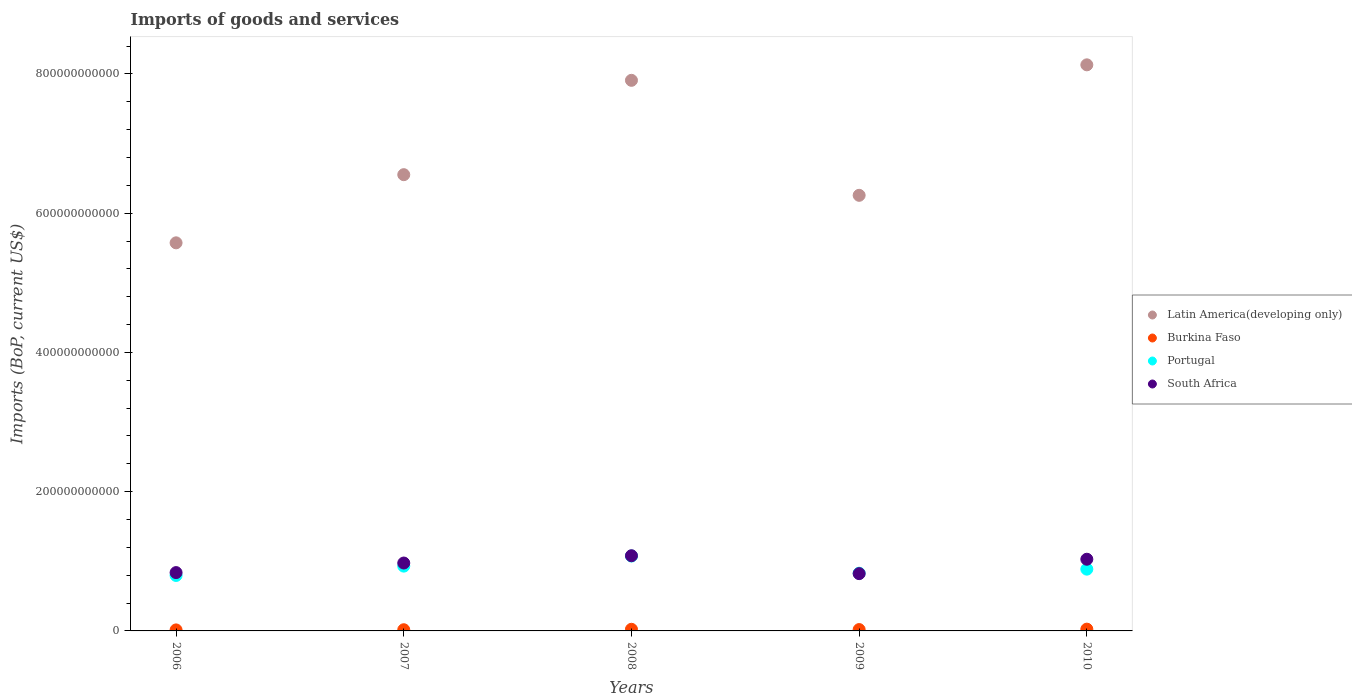What is the amount spent on imports in Latin America(developing only) in 2008?
Make the answer very short. 7.91e+11. Across all years, what is the maximum amount spent on imports in Latin America(developing only)?
Give a very brief answer. 8.13e+11. Across all years, what is the minimum amount spent on imports in Latin America(developing only)?
Your response must be concise. 5.57e+11. In which year was the amount spent on imports in South Africa maximum?
Provide a succinct answer. 2008. In which year was the amount spent on imports in Latin America(developing only) minimum?
Your answer should be compact. 2006. What is the total amount spent on imports in Portugal in the graph?
Give a very brief answer. 4.52e+11. What is the difference between the amount spent on imports in Burkina Faso in 2008 and that in 2009?
Offer a very short reply. 4.11e+08. What is the difference between the amount spent on imports in Latin America(developing only) in 2009 and the amount spent on imports in Burkina Faso in 2007?
Your response must be concise. 6.24e+11. What is the average amount spent on imports in Burkina Faso per year?
Your answer should be very brief. 2.00e+09. In the year 2010, what is the difference between the amount spent on imports in South Africa and amount spent on imports in Portugal?
Offer a very short reply. 1.42e+1. What is the ratio of the amount spent on imports in Burkina Faso in 2008 to that in 2009?
Your answer should be compact. 1.21. Is the amount spent on imports in Burkina Faso in 2009 less than that in 2010?
Give a very brief answer. Yes. What is the difference between the highest and the second highest amount spent on imports in Latin America(developing only)?
Your answer should be very brief. 2.23e+1. What is the difference between the highest and the lowest amount spent on imports in Portugal?
Your answer should be compact. 2.79e+1. Is the sum of the amount spent on imports in Burkina Faso in 2006 and 2009 greater than the maximum amount spent on imports in Latin America(developing only) across all years?
Give a very brief answer. No. Is it the case that in every year, the sum of the amount spent on imports in South Africa and amount spent on imports in Latin America(developing only)  is greater than the amount spent on imports in Burkina Faso?
Keep it short and to the point. Yes. How many dotlines are there?
Keep it short and to the point. 4. What is the difference between two consecutive major ticks on the Y-axis?
Provide a succinct answer. 2.00e+11. Are the values on the major ticks of Y-axis written in scientific E-notation?
Keep it short and to the point. No. Does the graph contain grids?
Your answer should be compact. No. How many legend labels are there?
Provide a short and direct response. 4. What is the title of the graph?
Keep it short and to the point. Imports of goods and services. Does "Congo (Democratic)" appear as one of the legend labels in the graph?
Provide a short and direct response. No. What is the label or title of the X-axis?
Your answer should be very brief. Years. What is the label or title of the Y-axis?
Provide a short and direct response. Imports (BoP, current US$). What is the Imports (BoP, current US$) of Latin America(developing only) in 2006?
Your answer should be very brief. 5.57e+11. What is the Imports (BoP, current US$) in Burkina Faso in 2006?
Offer a very short reply. 1.45e+09. What is the Imports (BoP, current US$) in Portugal in 2006?
Your answer should be very brief. 7.96e+1. What is the Imports (BoP, current US$) in South Africa in 2006?
Provide a short and direct response. 8.38e+1. What is the Imports (BoP, current US$) in Latin America(developing only) in 2007?
Your answer should be very brief. 6.55e+11. What is the Imports (BoP, current US$) of Burkina Faso in 2007?
Keep it short and to the point. 1.70e+09. What is the Imports (BoP, current US$) of Portugal in 2007?
Give a very brief answer. 9.31e+1. What is the Imports (BoP, current US$) of South Africa in 2007?
Provide a succinct answer. 9.75e+1. What is the Imports (BoP, current US$) in Latin America(developing only) in 2008?
Provide a short and direct response. 7.91e+11. What is the Imports (BoP, current US$) in Burkina Faso in 2008?
Give a very brief answer. 2.35e+09. What is the Imports (BoP, current US$) in Portugal in 2008?
Give a very brief answer. 1.08e+11. What is the Imports (BoP, current US$) in South Africa in 2008?
Give a very brief answer. 1.08e+11. What is the Imports (BoP, current US$) in Latin America(developing only) in 2009?
Provide a short and direct response. 6.26e+11. What is the Imports (BoP, current US$) in Burkina Faso in 2009?
Keep it short and to the point. 1.94e+09. What is the Imports (BoP, current US$) in Portugal in 2009?
Ensure brevity in your answer.  8.29e+1. What is the Imports (BoP, current US$) in South Africa in 2009?
Your answer should be compact. 8.23e+1. What is the Imports (BoP, current US$) of Latin America(developing only) in 2010?
Your response must be concise. 8.13e+11. What is the Imports (BoP, current US$) of Burkina Faso in 2010?
Offer a very short reply. 2.56e+09. What is the Imports (BoP, current US$) in Portugal in 2010?
Make the answer very short. 8.87e+1. What is the Imports (BoP, current US$) in South Africa in 2010?
Provide a succinct answer. 1.03e+11. Across all years, what is the maximum Imports (BoP, current US$) of Latin America(developing only)?
Offer a terse response. 8.13e+11. Across all years, what is the maximum Imports (BoP, current US$) of Burkina Faso?
Give a very brief answer. 2.56e+09. Across all years, what is the maximum Imports (BoP, current US$) of Portugal?
Your answer should be very brief. 1.08e+11. Across all years, what is the maximum Imports (BoP, current US$) of South Africa?
Offer a very short reply. 1.08e+11. Across all years, what is the minimum Imports (BoP, current US$) in Latin America(developing only)?
Keep it short and to the point. 5.57e+11. Across all years, what is the minimum Imports (BoP, current US$) of Burkina Faso?
Make the answer very short. 1.45e+09. Across all years, what is the minimum Imports (BoP, current US$) of Portugal?
Your answer should be compact. 7.96e+1. Across all years, what is the minimum Imports (BoP, current US$) in South Africa?
Your response must be concise. 8.23e+1. What is the total Imports (BoP, current US$) of Latin America(developing only) in the graph?
Ensure brevity in your answer.  3.44e+12. What is the total Imports (BoP, current US$) of Burkina Faso in the graph?
Offer a terse response. 1.00e+1. What is the total Imports (BoP, current US$) in Portugal in the graph?
Your answer should be compact. 4.52e+11. What is the total Imports (BoP, current US$) in South Africa in the graph?
Provide a succinct answer. 4.74e+11. What is the difference between the Imports (BoP, current US$) in Latin America(developing only) in 2006 and that in 2007?
Keep it short and to the point. -9.79e+1. What is the difference between the Imports (BoP, current US$) of Burkina Faso in 2006 and that in 2007?
Provide a short and direct response. -2.51e+08. What is the difference between the Imports (BoP, current US$) in Portugal in 2006 and that in 2007?
Your answer should be very brief. -1.34e+1. What is the difference between the Imports (BoP, current US$) in South Africa in 2006 and that in 2007?
Provide a short and direct response. -1.37e+1. What is the difference between the Imports (BoP, current US$) in Latin America(developing only) in 2006 and that in 2008?
Keep it short and to the point. -2.33e+11. What is the difference between the Imports (BoP, current US$) of Burkina Faso in 2006 and that in 2008?
Your answer should be very brief. -9.02e+08. What is the difference between the Imports (BoP, current US$) in Portugal in 2006 and that in 2008?
Keep it short and to the point. -2.79e+1. What is the difference between the Imports (BoP, current US$) of South Africa in 2006 and that in 2008?
Make the answer very short. -2.42e+1. What is the difference between the Imports (BoP, current US$) of Latin America(developing only) in 2006 and that in 2009?
Keep it short and to the point. -6.82e+1. What is the difference between the Imports (BoP, current US$) in Burkina Faso in 2006 and that in 2009?
Keep it short and to the point. -4.91e+08. What is the difference between the Imports (BoP, current US$) of Portugal in 2006 and that in 2009?
Provide a short and direct response. -3.25e+09. What is the difference between the Imports (BoP, current US$) in South Africa in 2006 and that in 2009?
Your answer should be very brief. 1.49e+09. What is the difference between the Imports (BoP, current US$) of Latin America(developing only) in 2006 and that in 2010?
Offer a very short reply. -2.56e+11. What is the difference between the Imports (BoP, current US$) of Burkina Faso in 2006 and that in 2010?
Provide a succinct answer. -1.11e+09. What is the difference between the Imports (BoP, current US$) in Portugal in 2006 and that in 2010?
Ensure brevity in your answer.  -9.06e+09. What is the difference between the Imports (BoP, current US$) of South Africa in 2006 and that in 2010?
Offer a very short reply. -1.92e+1. What is the difference between the Imports (BoP, current US$) of Latin America(developing only) in 2007 and that in 2008?
Give a very brief answer. -1.36e+11. What is the difference between the Imports (BoP, current US$) in Burkina Faso in 2007 and that in 2008?
Keep it short and to the point. -6.51e+08. What is the difference between the Imports (BoP, current US$) in Portugal in 2007 and that in 2008?
Your response must be concise. -1.45e+1. What is the difference between the Imports (BoP, current US$) in South Africa in 2007 and that in 2008?
Give a very brief answer. -1.05e+1. What is the difference between the Imports (BoP, current US$) in Latin America(developing only) in 2007 and that in 2009?
Offer a terse response. 2.96e+1. What is the difference between the Imports (BoP, current US$) of Burkina Faso in 2007 and that in 2009?
Provide a short and direct response. -2.40e+08. What is the difference between the Imports (BoP, current US$) of Portugal in 2007 and that in 2009?
Keep it short and to the point. 1.02e+1. What is the difference between the Imports (BoP, current US$) of South Africa in 2007 and that in 2009?
Make the answer very short. 1.52e+1. What is the difference between the Imports (BoP, current US$) of Latin America(developing only) in 2007 and that in 2010?
Offer a very short reply. -1.58e+11. What is the difference between the Imports (BoP, current US$) of Burkina Faso in 2007 and that in 2010?
Provide a short and direct response. -8.55e+08. What is the difference between the Imports (BoP, current US$) in Portugal in 2007 and that in 2010?
Ensure brevity in your answer.  4.36e+09. What is the difference between the Imports (BoP, current US$) in South Africa in 2007 and that in 2010?
Your answer should be compact. -5.45e+09. What is the difference between the Imports (BoP, current US$) of Latin America(developing only) in 2008 and that in 2009?
Offer a very short reply. 1.65e+11. What is the difference between the Imports (BoP, current US$) of Burkina Faso in 2008 and that in 2009?
Ensure brevity in your answer.  4.11e+08. What is the difference between the Imports (BoP, current US$) of Portugal in 2008 and that in 2009?
Your answer should be very brief. 2.47e+1. What is the difference between the Imports (BoP, current US$) in South Africa in 2008 and that in 2009?
Provide a succinct answer. 2.57e+1. What is the difference between the Imports (BoP, current US$) of Latin America(developing only) in 2008 and that in 2010?
Provide a succinct answer. -2.23e+1. What is the difference between the Imports (BoP, current US$) in Burkina Faso in 2008 and that in 2010?
Your answer should be compact. -2.04e+08. What is the difference between the Imports (BoP, current US$) of Portugal in 2008 and that in 2010?
Make the answer very short. 1.89e+1. What is the difference between the Imports (BoP, current US$) in South Africa in 2008 and that in 2010?
Give a very brief answer. 5.02e+09. What is the difference between the Imports (BoP, current US$) in Latin America(developing only) in 2009 and that in 2010?
Provide a short and direct response. -1.87e+11. What is the difference between the Imports (BoP, current US$) in Burkina Faso in 2009 and that in 2010?
Ensure brevity in your answer.  -6.15e+08. What is the difference between the Imports (BoP, current US$) in Portugal in 2009 and that in 2010?
Offer a terse response. -5.81e+09. What is the difference between the Imports (BoP, current US$) of South Africa in 2009 and that in 2010?
Offer a very short reply. -2.07e+1. What is the difference between the Imports (BoP, current US$) in Latin America(developing only) in 2006 and the Imports (BoP, current US$) in Burkina Faso in 2007?
Your answer should be very brief. 5.56e+11. What is the difference between the Imports (BoP, current US$) in Latin America(developing only) in 2006 and the Imports (BoP, current US$) in Portugal in 2007?
Your response must be concise. 4.64e+11. What is the difference between the Imports (BoP, current US$) in Latin America(developing only) in 2006 and the Imports (BoP, current US$) in South Africa in 2007?
Provide a succinct answer. 4.60e+11. What is the difference between the Imports (BoP, current US$) in Burkina Faso in 2006 and the Imports (BoP, current US$) in Portugal in 2007?
Offer a terse response. -9.16e+1. What is the difference between the Imports (BoP, current US$) of Burkina Faso in 2006 and the Imports (BoP, current US$) of South Africa in 2007?
Your answer should be compact. -9.61e+1. What is the difference between the Imports (BoP, current US$) in Portugal in 2006 and the Imports (BoP, current US$) in South Africa in 2007?
Offer a terse response. -1.79e+1. What is the difference between the Imports (BoP, current US$) of Latin America(developing only) in 2006 and the Imports (BoP, current US$) of Burkina Faso in 2008?
Keep it short and to the point. 5.55e+11. What is the difference between the Imports (BoP, current US$) in Latin America(developing only) in 2006 and the Imports (BoP, current US$) in Portugal in 2008?
Give a very brief answer. 4.50e+11. What is the difference between the Imports (BoP, current US$) of Latin America(developing only) in 2006 and the Imports (BoP, current US$) of South Africa in 2008?
Give a very brief answer. 4.49e+11. What is the difference between the Imports (BoP, current US$) in Burkina Faso in 2006 and the Imports (BoP, current US$) in Portugal in 2008?
Make the answer very short. -1.06e+11. What is the difference between the Imports (BoP, current US$) of Burkina Faso in 2006 and the Imports (BoP, current US$) of South Africa in 2008?
Provide a succinct answer. -1.07e+11. What is the difference between the Imports (BoP, current US$) in Portugal in 2006 and the Imports (BoP, current US$) in South Africa in 2008?
Provide a short and direct response. -2.83e+1. What is the difference between the Imports (BoP, current US$) of Latin America(developing only) in 2006 and the Imports (BoP, current US$) of Burkina Faso in 2009?
Give a very brief answer. 5.55e+11. What is the difference between the Imports (BoP, current US$) of Latin America(developing only) in 2006 and the Imports (BoP, current US$) of Portugal in 2009?
Ensure brevity in your answer.  4.74e+11. What is the difference between the Imports (BoP, current US$) in Latin America(developing only) in 2006 and the Imports (BoP, current US$) in South Africa in 2009?
Provide a short and direct response. 4.75e+11. What is the difference between the Imports (BoP, current US$) in Burkina Faso in 2006 and the Imports (BoP, current US$) in Portugal in 2009?
Provide a succinct answer. -8.14e+1. What is the difference between the Imports (BoP, current US$) in Burkina Faso in 2006 and the Imports (BoP, current US$) in South Africa in 2009?
Make the answer very short. -8.08e+1. What is the difference between the Imports (BoP, current US$) in Portugal in 2006 and the Imports (BoP, current US$) in South Africa in 2009?
Offer a very short reply. -2.63e+09. What is the difference between the Imports (BoP, current US$) in Latin America(developing only) in 2006 and the Imports (BoP, current US$) in Burkina Faso in 2010?
Offer a terse response. 5.55e+11. What is the difference between the Imports (BoP, current US$) of Latin America(developing only) in 2006 and the Imports (BoP, current US$) of Portugal in 2010?
Make the answer very short. 4.69e+11. What is the difference between the Imports (BoP, current US$) of Latin America(developing only) in 2006 and the Imports (BoP, current US$) of South Africa in 2010?
Your response must be concise. 4.54e+11. What is the difference between the Imports (BoP, current US$) of Burkina Faso in 2006 and the Imports (BoP, current US$) of Portugal in 2010?
Offer a very short reply. -8.73e+1. What is the difference between the Imports (BoP, current US$) in Burkina Faso in 2006 and the Imports (BoP, current US$) in South Africa in 2010?
Offer a very short reply. -1.02e+11. What is the difference between the Imports (BoP, current US$) in Portugal in 2006 and the Imports (BoP, current US$) in South Africa in 2010?
Your response must be concise. -2.33e+1. What is the difference between the Imports (BoP, current US$) in Latin America(developing only) in 2007 and the Imports (BoP, current US$) in Burkina Faso in 2008?
Provide a short and direct response. 6.53e+11. What is the difference between the Imports (BoP, current US$) of Latin America(developing only) in 2007 and the Imports (BoP, current US$) of Portugal in 2008?
Provide a succinct answer. 5.48e+11. What is the difference between the Imports (BoP, current US$) in Latin America(developing only) in 2007 and the Imports (BoP, current US$) in South Africa in 2008?
Provide a short and direct response. 5.47e+11. What is the difference between the Imports (BoP, current US$) of Burkina Faso in 2007 and the Imports (BoP, current US$) of Portugal in 2008?
Provide a succinct answer. -1.06e+11. What is the difference between the Imports (BoP, current US$) in Burkina Faso in 2007 and the Imports (BoP, current US$) in South Africa in 2008?
Provide a succinct answer. -1.06e+11. What is the difference between the Imports (BoP, current US$) of Portugal in 2007 and the Imports (BoP, current US$) of South Africa in 2008?
Offer a terse response. -1.49e+1. What is the difference between the Imports (BoP, current US$) of Latin America(developing only) in 2007 and the Imports (BoP, current US$) of Burkina Faso in 2009?
Make the answer very short. 6.53e+11. What is the difference between the Imports (BoP, current US$) of Latin America(developing only) in 2007 and the Imports (BoP, current US$) of Portugal in 2009?
Keep it short and to the point. 5.72e+11. What is the difference between the Imports (BoP, current US$) in Latin America(developing only) in 2007 and the Imports (BoP, current US$) in South Africa in 2009?
Give a very brief answer. 5.73e+11. What is the difference between the Imports (BoP, current US$) in Burkina Faso in 2007 and the Imports (BoP, current US$) in Portugal in 2009?
Provide a succinct answer. -8.12e+1. What is the difference between the Imports (BoP, current US$) in Burkina Faso in 2007 and the Imports (BoP, current US$) in South Africa in 2009?
Give a very brief answer. -8.06e+1. What is the difference between the Imports (BoP, current US$) in Portugal in 2007 and the Imports (BoP, current US$) in South Africa in 2009?
Your answer should be compact. 1.08e+1. What is the difference between the Imports (BoP, current US$) of Latin America(developing only) in 2007 and the Imports (BoP, current US$) of Burkina Faso in 2010?
Your answer should be compact. 6.53e+11. What is the difference between the Imports (BoP, current US$) of Latin America(developing only) in 2007 and the Imports (BoP, current US$) of Portugal in 2010?
Give a very brief answer. 5.67e+11. What is the difference between the Imports (BoP, current US$) in Latin America(developing only) in 2007 and the Imports (BoP, current US$) in South Africa in 2010?
Your answer should be compact. 5.52e+11. What is the difference between the Imports (BoP, current US$) in Burkina Faso in 2007 and the Imports (BoP, current US$) in Portugal in 2010?
Provide a succinct answer. -8.70e+1. What is the difference between the Imports (BoP, current US$) in Burkina Faso in 2007 and the Imports (BoP, current US$) in South Africa in 2010?
Give a very brief answer. -1.01e+11. What is the difference between the Imports (BoP, current US$) in Portugal in 2007 and the Imports (BoP, current US$) in South Africa in 2010?
Your answer should be compact. -9.89e+09. What is the difference between the Imports (BoP, current US$) in Latin America(developing only) in 2008 and the Imports (BoP, current US$) in Burkina Faso in 2009?
Provide a succinct answer. 7.89e+11. What is the difference between the Imports (BoP, current US$) of Latin America(developing only) in 2008 and the Imports (BoP, current US$) of Portugal in 2009?
Offer a terse response. 7.08e+11. What is the difference between the Imports (BoP, current US$) in Latin America(developing only) in 2008 and the Imports (BoP, current US$) in South Africa in 2009?
Your response must be concise. 7.08e+11. What is the difference between the Imports (BoP, current US$) in Burkina Faso in 2008 and the Imports (BoP, current US$) in Portugal in 2009?
Give a very brief answer. -8.05e+1. What is the difference between the Imports (BoP, current US$) of Burkina Faso in 2008 and the Imports (BoP, current US$) of South Africa in 2009?
Ensure brevity in your answer.  -7.99e+1. What is the difference between the Imports (BoP, current US$) in Portugal in 2008 and the Imports (BoP, current US$) in South Africa in 2009?
Make the answer very short. 2.53e+1. What is the difference between the Imports (BoP, current US$) of Latin America(developing only) in 2008 and the Imports (BoP, current US$) of Burkina Faso in 2010?
Your answer should be compact. 7.88e+11. What is the difference between the Imports (BoP, current US$) in Latin America(developing only) in 2008 and the Imports (BoP, current US$) in Portugal in 2010?
Offer a very short reply. 7.02e+11. What is the difference between the Imports (BoP, current US$) in Latin America(developing only) in 2008 and the Imports (BoP, current US$) in South Africa in 2010?
Your response must be concise. 6.88e+11. What is the difference between the Imports (BoP, current US$) in Burkina Faso in 2008 and the Imports (BoP, current US$) in Portugal in 2010?
Give a very brief answer. -8.64e+1. What is the difference between the Imports (BoP, current US$) of Burkina Faso in 2008 and the Imports (BoP, current US$) of South Africa in 2010?
Ensure brevity in your answer.  -1.01e+11. What is the difference between the Imports (BoP, current US$) of Portugal in 2008 and the Imports (BoP, current US$) of South Africa in 2010?
Offer a terse response. 4.62e+09. What is the difference between the Imports (BoP, current US$) of Latin America(developing only) in 2009 and the Imports (BoP, current US$) of Burkina Faso in 2010?
Provide a succinct answer. 6.23e+11. What is the difference between the Imports (BoP, current US$) in Latin America(developing only) in 2009 and the Imports (BoP, current US$) in Portugal in 2010?
Ensure brevity in your answer.  5.37e+11. What is the difference between the Imports (BoP, current US$) of Latin America(developing only) in 2009 and the Imports (BoP, current US$) of South Africa in 2010?
Offer a very short reply. 5.23e+11. What is the difference between the Imports (BoP, current US$) of Burkina Faso in 2009 and the Imports (BoP, current US$) of Portugal in 2010?
Keep it short and to the point. -8.68e+1. What is the difference between the Imports (BoP, current US$) in Burkina Faso in 2009 and the Imports (BoP, current US$) in South Africa in 2010?
Provide a succinct answer. -1.01e+11. What is the difference between the Imports (BoP, current US$) of Portugal in 2009 and the Imports (BoP, current US$) of South Africa in 2010?
Your response must be concise. -2.01e+1. What is the average Imports (BoP, current US$) of Latin America(developing only) per year?
Give a very brief answer. 6.88e+11. What is the average Imports (BoP, current US$) in Burkina Faso per year?
Offer a very short reply. 2.00e+09. What is the average Imports (BoP, current US$) of Portugal per year?
Provide a succinct answer. 9.04e+1. What is the average Imports (BoP, current US$) of South Africa per year?
Provide a short and direct response. 9.49e+1. In the year 2006, what is the difference between the Imports (BoP, current US$) in Latin America(developing only) and Imports (BoP, current US$) in Burkina Faso?
Give a very brief answer. 5.56e+11. In the year 2006, what is the difference between the Imports (BoP, current US$) in Latin America(developing only) and Imports (BoP, current US$) in Portugal?
Make the answer very short. 4.78e+11. In the year 2006, what is the difference between the Imports (BoP, current US$) of Latin America(developing only) and Imports (BoP, current US$) of South Africa?
Provide a short and direct response. 4.74e+11. In the year 2006, what is the difference between the Imports (BoP, current US$) in Burkina Faso and Imports (BoP, current US$) in Portugal?
Give a very brief answer. -7.82e+1. In the year 2006, what is the difference between the Imports (BoP, current US$) in Burkina Faso and Imports (BoP, current US$) in South Africa?
Your response must be concise. -8.23e+1. In the year 2006, what is the difference between the Imports (BoP, current US$) in Portugal and Imports (BoP, current US$) in South Africa?
Make the answer very short. -4.12e+09. In the year 2007, what is the difference between the Imports (BoP, current US$) of Latin America(developing only) and Imports (BoP, current US$) of Burkina Faso?
Keep it short and to the point. 6.54e+11. In the year 2007, what is the difference between the Imports (BoP, current US$) in Latin America(developing only) and Imports (BoP, current US$) in Portugal?
Your response must be concise. 5.62e+11. In the year 2007, what is the difference between the Imports (BoP, current US$) of Latin America(developing only) and Imports (BoP, current US$) of South Africa?
Offer a terse response. 5.58e+11. In the year 2007, what is the difference between the Imports (BoP, current US$) in Burkina Faso and Imports (BoP, current US$) in Portugal?
Provide a short and direct response. -9.14e+1. In the year 2007, what is the difference between the Imports (BoP, current US$) in Burkina Faso and Imports (BoP, current US$) in South Africa?
Make the answer very short. -9.58e+1. In the year 2007, what is the difference between the Imports (BoP, current US$) of Portugal and Imports (BoP, current US$) of South Africa?
Your response must be concise. -4.44e+09. In the year 2008, what is the difference between the Imports (BoP, current US$) in Latin America(developing only) and Imports (BoP, current US$) in Burkina Faso?
Give a very brief answer. 7.88e+11. In the year 2008, what is the difference between the Imports (BoP, current US$) in Latin America(developing only) and Imports (BoP, current US$) in Portugal?
Your response must be concise. 6.83e+11. In the year 2008, what is the difference between the Imports (BoP, current US$) of Latin America(developing only) and Imports (BoP, current US$) of South Africa?
Your answer should be compact. 6.83e+11. In the year 2008, what is the difference between the Imports (BoP, current US$) of Burkina Faso and Imports (BoP, current US$) of Portugal?
Give a very brief answer. -1.05e+11. In the year 2008, what is the difference between the Imports (BoP, current US$) of Burkina Faso and Imports (BoP, current US$) of South Africa?
Make the answer very short. -1.06e+11. In the year 2008, what is the difference between the Imports (BoP, current US$) in Portugal and Imports (BoP, current US$) in South Africa?
Provide a succinct answer. -4.01e+08. In the year 2009, what is the difference between the Imports (BoP, current US$) in Latin America(developing only) and Imports (BoP, current US$) in Burkina Faso?
Your answer should be compact. 6.24e+11. In the year 2009, what is the difference between the Imports (BoP, current US$) in Latin America(developing only) and Imports (BoP, current US$) in Portugal?
Your answer should be compact. 5.43e+11. In the year 2009, what is the difference between the Imports (BoP, current US$) of Latin America(developing only) and Imports (BoP, current US$) of South Africa?
Provide a succinct answer. 5.43e+11. In the year 2009, what is the difference between the Imports (BoP, current US$) in Burkina Faso and Imports (BoP, current US$) in Portugal?
Offer a terse response. -8.10e+1. In the year 2009, what is the difference between the Imports (BoP, current US$) of Burkina Faso and Imports (BoP, current US$) of South Africa?
Offer a very short reply. -8.03e+1. In the year 2009, what is the difference between the Imports (BoP, current US$) of Portugal and Imports (BoP, current US$) of South Africa?
Offer a terse response. 6.18e+08. In the year 2010, what is the difference between the Imports (BoP, current US$) of Latin America(developing only) and Imports (BoP, current US$) of Burkina Faso?
Provide a short and direct response. 8.10e+11. In the year 2010, what is the difference between the Imports (BoP, current US$) of Latin America(developing only) and Imports (BoP, current US$) of Portugal?
Provide a short and direct response. 7.24e+11. In the year 2010, what is the difference between the Imports (BoP, current US$) of Latin America(developing only) and Imports (BoP, current US$) of South Africa?
Your answer should be compact. 7.10e+11. In the year 2010, what is the difference between the Imports (BoP, current US$) in Burkina Faso and Imports (BoP, current US$) in Portugal?
Provide a short and direct response. -8.62e+1. In the year 2010, what is the difference between the Imports (BoP, current US$) in Burkina Faso and Imports (BoP, current US$) in South Africa?
Offer a very short reply. -1.00e+11. In the year 2010, what is the difference between the Imports (BoP, current US$) in Portugal and Imports (BoP, current US$) in South Africa?
Provide a short and direct response. -1.42e+1. What is the ratio of the Imports (BoP, current US$) of Latin America(developing only) in 2006 to that in 2007?
Ensure brevity in your answer.  0.85. What is the ratio of the Imports (BoP, current US$) in Burkina Faso in 2006 to that in 2007?
Provide a short and direct response. 0.85. What is the ratio of the Imports (BoP, current US$) of Portugal in 2006 to that in 2007?
Give a very brief answer. 0.86. What is the ratio of the Imports (BoP, current US$) of South Africa in 2006 to that in 2007?
Provide a succinct answer. 0.86. What is the ratio of the Imports (BoP, current US$) in Latin America(developing only) in 2006 to that in 2008?
Your response must be concise. 0.7. What is the ratio of the Imports (BoP, current US$) of Burkina Faso in 2006 to that in 2008?
Your response must be concise. 0.62. What is the ratio of the Imports (BoP, current US$) of Portugal in 2006 to that in 2008?
Your response must be concise. 0.74. What is the ratio of the Imports (BoP, current US$) in South Africa in 2006 to that in 2008?
Your response must be concise. 0.78. What is the ratio of the Imports (BoP, current US$) of Latin America(developing only) in 2006 to that in 2009?
Offer a terse response. 0.89. What is the ratio of the Imports (BoP, current US$) of Burkina Faso in 2006 to that in 2009?
Ensure brevity in your answer.  0.75. What is the ratio of the Imports (BoP, current US$) of Portugal in 2006 to that in 2009?
Provide a short and direct response. 0.96. What is the ratio of the Imports (BoP, current US$) of South Africa in 2006 to that in 2009?
Offer a very short reply. 1.02. What is the ratio of the Imports (BoP, current US$) of Latin America(developing only) in 2006 to that in 2010?
Offer a very short reply. 0.69. What is the ratio of the Imports (BoP, current US$) in Burkina Faso in 2006 to that in 2010?
Your response must be concise. 0.57. What is the ratio of the Imports (BoP, current US$) in Portugal in 2006 to that in 2010?
Your answer should be very brief. 0.9. What is the ratio of the Imports (BoP, current US$) of South Africa in 2006 to that in 2010?
Offer a very short reply. 0.81. What is the ratio of the Imports (BoP, current US$) of Latin America(developing only) in 2007 to that in 2008?
Keep it short and to the point. 0.83. What is the ratio of the Imports (BoP, current US$) in Burkina Faso in 2007 to that in 2008?
Your response must be concise. 0.72. What is the ratio of the Imports (BoP, current US$) of Portugal in 2007 to that in 2008?
Keep it short and to the point. 0.87. What is the ratio of the Imports (BoP, current US$) in South Africa in 2007 to that in 2008?
Ensure brevity in your answer.  0.9. What is the ratio of the Imports (BoP, current US$) of Latin America(developing only) in 2007 to that in 2009?
Provide a short and direct response. 1.05. What is the ratio of the Imports (BoP, current US$) of Burkina Faso in 2007 to that in 2009?
Ensure brevity in your answer.  0.88. What is the ratio of the Imports (BoP, current US$) of Portugal in 2007 to that in 2009?
Your answer should be compact. 1.12. What is the ratio of the Imports (BoP, current US$) in South Africa in 2007 to that in 2009?
Make the answer very short. 1.19. What is the ratio of the Imports (BoP, current US$) of Latin America(developing only) in 2007 to that in 2010?
Keep it short and to the point. 0.81. What is the ratio of the Imports (BoP, current US$) in Burkina Faso in 2007 to that in 2010?
Provide a short and direct response. 0.67. What is the ratio of the Imports (BoP, current US$) of Portugal in 2007 to that in 2010?
Ensure brevity in your answer.  1.05. What is the ratio of the Imports (BoP, current US$) in South Africa in 2007 to that in 2010?
Keep it short and to the point. 0.95. What is the ratio of the Imports (BoP, current US$) of Latin America(developing only) in 2008 to that in 2009?
Give a very brief answer. 1.26. What is the ratio of the Imports (BoP, current US$) in Burkina Faso in 2008 to that in 2009?
Offer a very short reply. 1.21. What is the ratio of the Imports (BoP, current US$) in Portugal in 2008 to that in 2009?
Your response must be concise. 1.3. What is the ratio of the Imports (BoP, current US$) of South Africa in 2008 to that in 2009?
Ensure brevity in your answer.  1.31. What is the ratio of the Imports (BoP, current US$) in Latin America(developing only) in 2008 to that in 2010?
Ensure brevity in your answer.  0.97. What is the ratio of the Imports (BoP, current US$) in Burkina Faso in 2008 to that in 2010?
Your response must be concise. 0.92. What is the ratio of the Imports (BoP, current US$) in Portugal in 2008 to that in 2010?
Provide a short and direct response. 1.21. What is the ratio of the Imports (BoP, current US$) of South Africa in 2008 to that in 2010?
Offer a very short reply. 1.05. What is the ratio of the Imports (BoP, current US$) in Latin America(developing only) in 2009 to that in 2010?
Make the answer very short. 0.77. What is the ratio of the Imports (BoP, current US$) of Burkina Faso in 2009 to that in 2010?
Make the answer very short. 0.76. What is the ratio of the Imports (BoP, current US$) in Portugal in 2009 to that in 2010?
Your answer should be very brief. 0.93. What is the ratio of the Imports (BoP, current US$) in South Africa in 2009 to that in 2010?
Provide a succinct answer. 0.8. What is the difference between the highest and the second highest Imports (BoP, current US$) of Latin America(developing only)?
Keep it short and to the point. 2.23e+1. What is the difference between the highest and the second highest Imports (BoP, current US$) of Burkina Faso?
Offer a terse response. 2.04e+08. What is the difference between the highest and the second highest Imports (BoP, current US$) in Portugal?
Give a very brief answer. 1.45e+1. What is the difference between the highest and the second highest Imports (BoP, current US$) in South Africa?
Your response must be concise. 5.02e+09. What is the difference between the highest and the lowest Imports (BoP, current US$) of Latin America(developing only)?
Make the answer very short. 2.56e+11. What is the difference between the highest and the lowest Imports (BoP, current US$) of Burkina Faso?
Make the answer very short. 1.11e+09. What is the difference between the highest and the lowest Imports (BoP, current US$) of Portugal?
Ensure brevity in your answer.  2.79e+1. What is the difference between the highest and the lowest Imports (BoP, current US$) of South Africa?
Provide a succinct answer. 2.57e+1. 